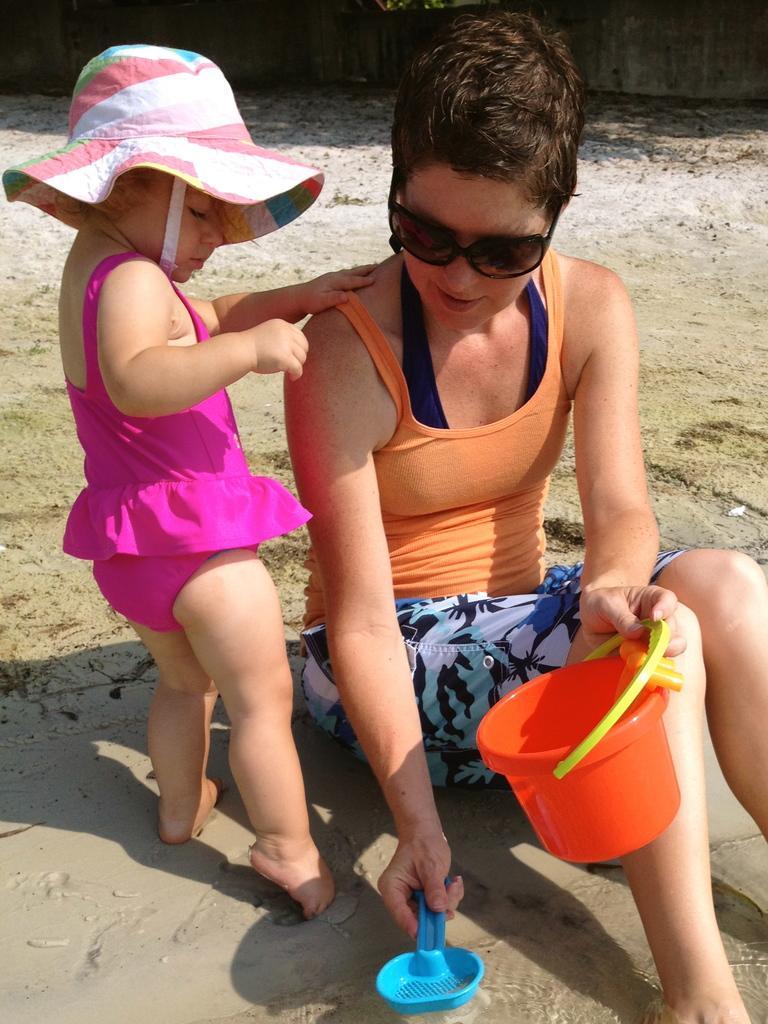In one or two sentences, can you explain what this image depicts? In this image I can see two people. I can see some objects. In the background, I can see the wall. 